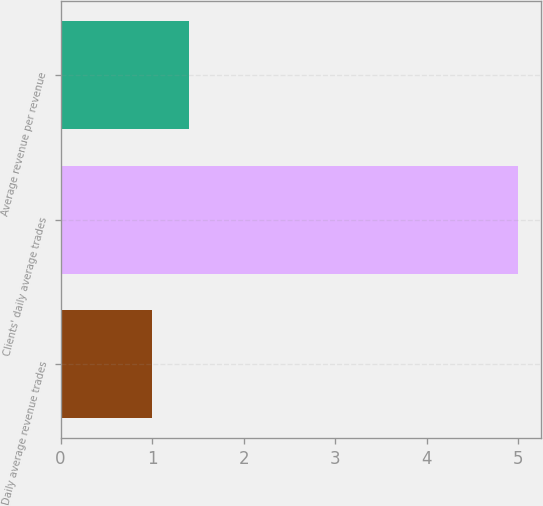Convert chart to OTSL. <chart><loc_0><loc_0><loc_500><loc_500><bar_chart><fcel>Daily average revenue trades<fcel>Clients' daily average trades<fcel>Average revenue per revenue<nl><fcel>1<fcel>5<fcel>1.4<nl></chart> 